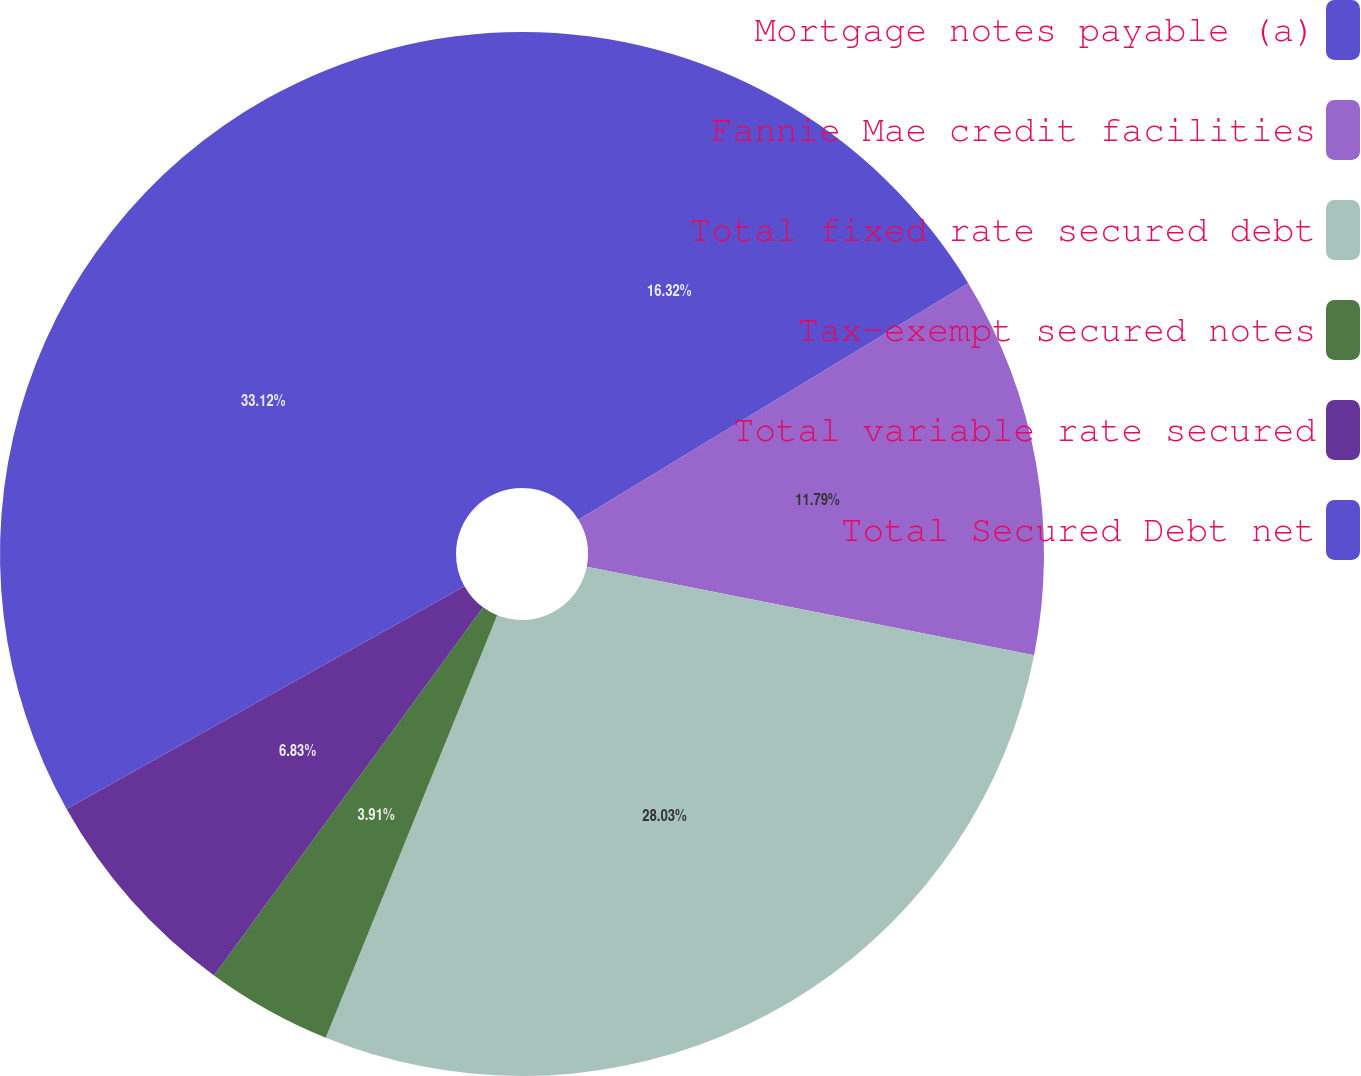<chart> <loc_0><loc_0><loc_500><loc_500><pie_chart><fcel>Mortgage notes payable (a)<fcel>Fannie Mae credit facilities<fcel>Total fixed rate secured debt<fcel>Tax-exempt secured notes<fcel>Total variable rate secured<fcel>Total Secured Debt net<nl><fcel>16.32%<fcel>11.79%<fcel>28.03%<fcel>3.91%<fcel>6.83%<fcel>33.13%<nl></chart> 